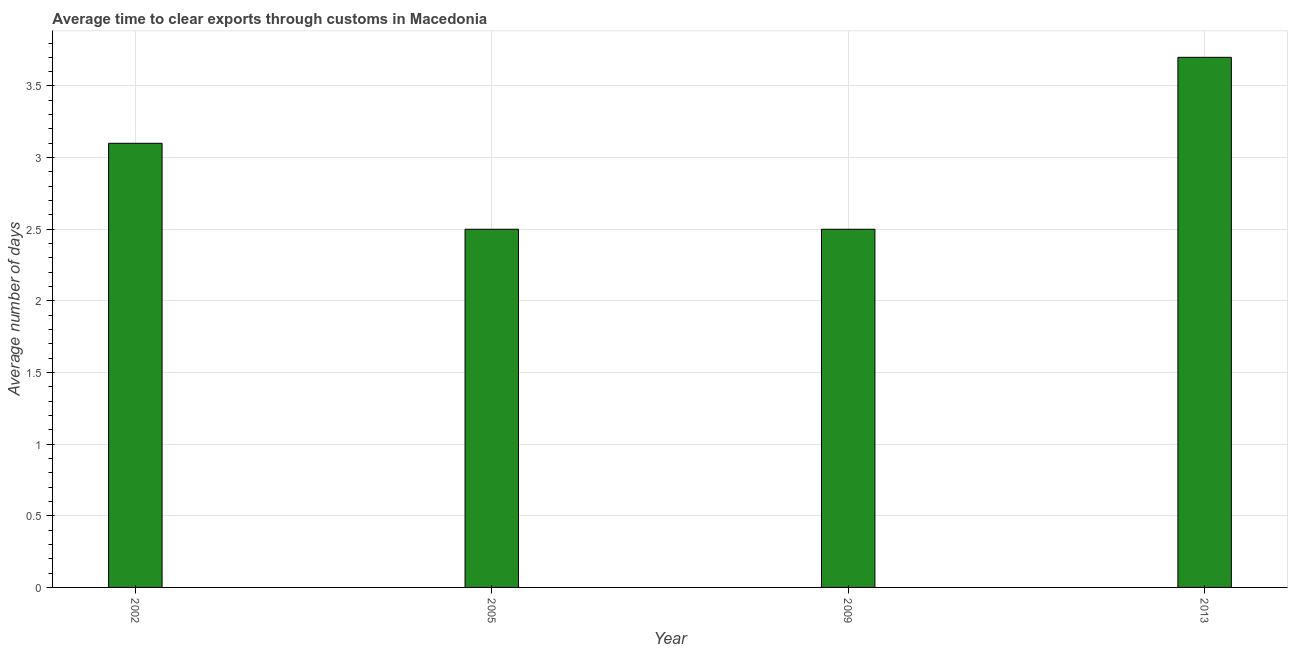Does the graph contain any zero values?
Your answer should be compact. No. What is the title of the graph?
Keep it short and to the point. Average time to clear exports through customs in Macedonia. What is the label or title of the X-axis?
Keep it short and to the point. Year. What is the label or title of the Y-axis?
Give a very brief answer. Average number of days. What is the time to clear exports through customs in 2005?
Offer a terse response. 2.5. Across all years, what is the maximum time to clear exports through customs?
Keep it short and to the point. 3.7. Across all years, what is the minimum time to clear exports through customs?
Make the answer very short. 2.5. What is the sum of the time to clear exports through customs?
Give a very brief answer. 11.8. What is the difference between the time to clear exports through customs in 2005 and 2009?
Keep it short and to the point. 0. What is the average time to clear exports through customs per year?
Offer a terse response. 2.95. What is the median time to clear exports through customs?
Keep it short and to the point. 2.8. In how many years, is the time to clear exports through customs greater than 2.2 days?
Your answer should be compact. 4. What is the ratio of the time to clear exports through customs in 2002 to that in 2009?
Make the answer very short. 1.24. Is the time to clear exports through customs in 2002 less than that in 2009?
Provide a short and direct response. No. Is the sum of the time to clear exports through customs in 2002 and 2009 greater than the maximum time to clear exports through customs across all years?
Your answer should be very brief. Yes. What is the difference between the highest and the lowest time to clear exports through customs?
Provide a succinct answer. 1.2. In how many years, is the time to clear exports through customs greater than the average time to clear exports through customs taken over all years?
Your answer should be compact. 2. How many bars are there?
Provide a succinct answer. 4. How many years are there in the graph?
Keep it short and to the point. 4. What is the difference between two consecutive major ticks on the Y-axis?
Your answer should be very brief. 0.5. Are the values on the major ticks of Y-axis written in scientific E-notation?
Your answer should be very brief. No. What is the Average number of days of 2005?
Offer a very short reply. 2.5. What is the Average number of days in 2013?
Your answer should be compact. 3.7. What is the difference between the Average number of days in 2005 and 2013?
Provide a short and direct response. -1.2. What is the ratio of the Average number of days in 2002 to that in 2005?
Your answer should be compact. 1.24. What is the ratio of the Average number of days in 2002 to that in 2009?
Give a very brief answer. 1.24. What is the ratio of the Average number of days in 2002 to that in 2013?
Your response must be concise. 0.84. What is the ratio of the Average number of days in 2005 to that in 2009?
Provide a succinct answer. 1. What is the ratio of the Average number of days in 2005 to that in 2013?
Give a very brief answer. 0.68. What is the ratio of the Average number of days in 2009 to that in 2013?
Your response must be concise. 0.68. 